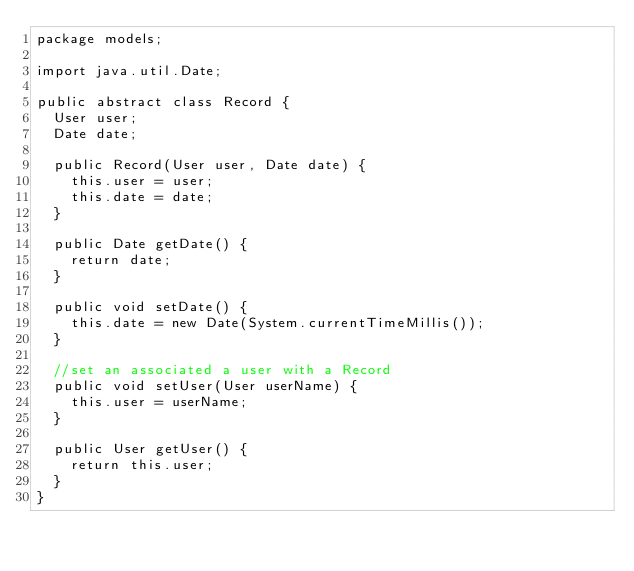<code> <loc_0><loc_0><loc_500><loc_500><_Java_>package models;

import java.util.Date;

public abstract class Record {
	User user;
	Date date;
	
	public Record(User user, Date date) {
		this.user = user;
		this.date = date;
	}

	public Date getDate() {
		return date;
	}
	
	public void setDate() {
		this.date = new Date(System.currentTimeMillis());
	}
	
	//set an associated a user with a Record
	public void setUser(User userName) {
		this.user = userName;
	}
	
	public User getUser() {
		return this.user;
	}
}
</code> 